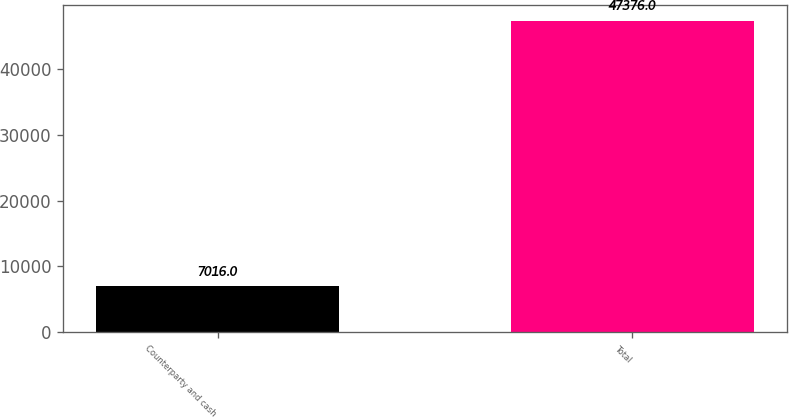Convert chart to OTSL. <chart><loc_0><loc_0><loc_500><loc_500><bar_chart><fcel>Counterparty and cash<fcel>Total<nl><fcel>7016<fcel>47376<nl></chart> 